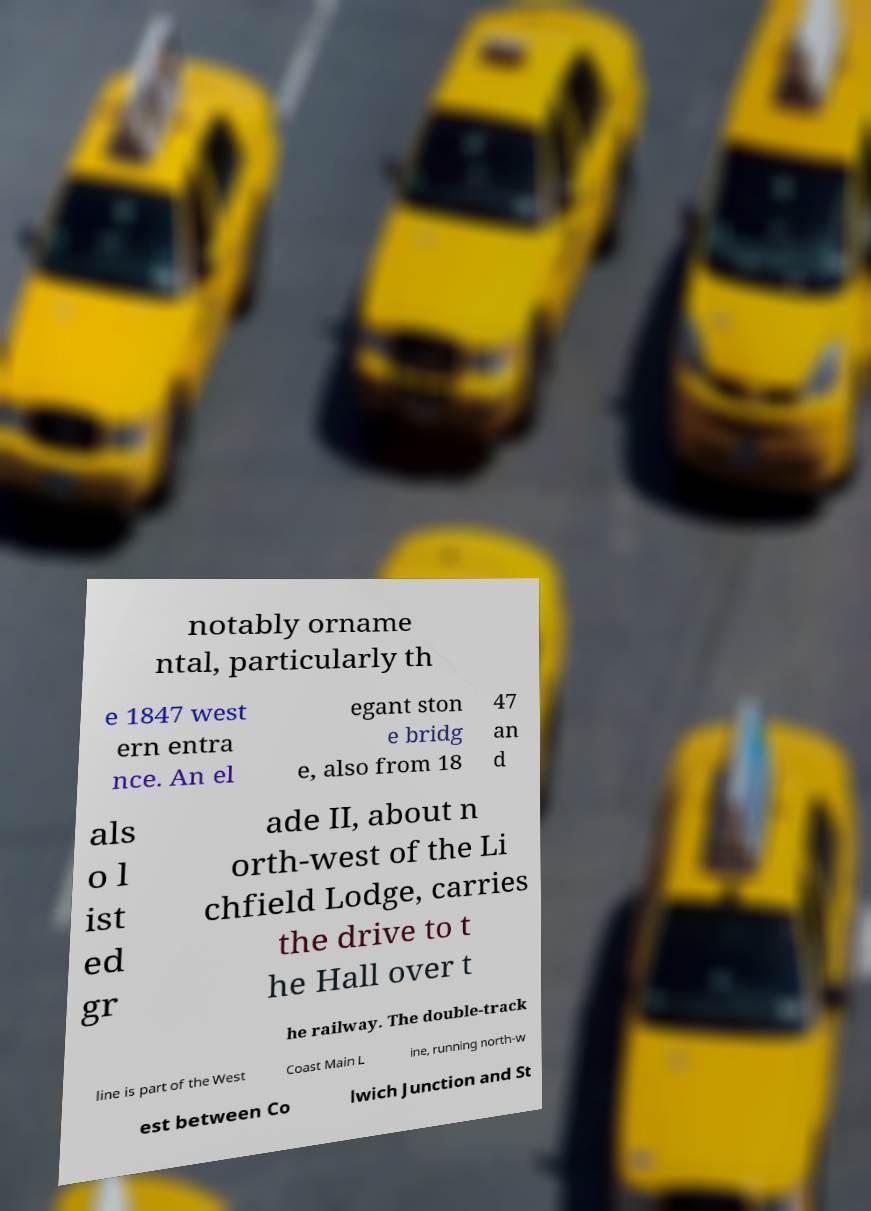For documentation purposes, I need the text within this image transcribed. Could you provide that? notably orname ntal, particularly th e 1847 west ern entra nce. An el egant ston e bridg e, also from 18 47 an d als o l ist ed gr ade II, about n orth-west of the Li chfield Lodge, carries the drive to t he Hall over t he railway. The double-track line is part of the West Coast Main L ine, running north-w est between Co lwich Junction and St 